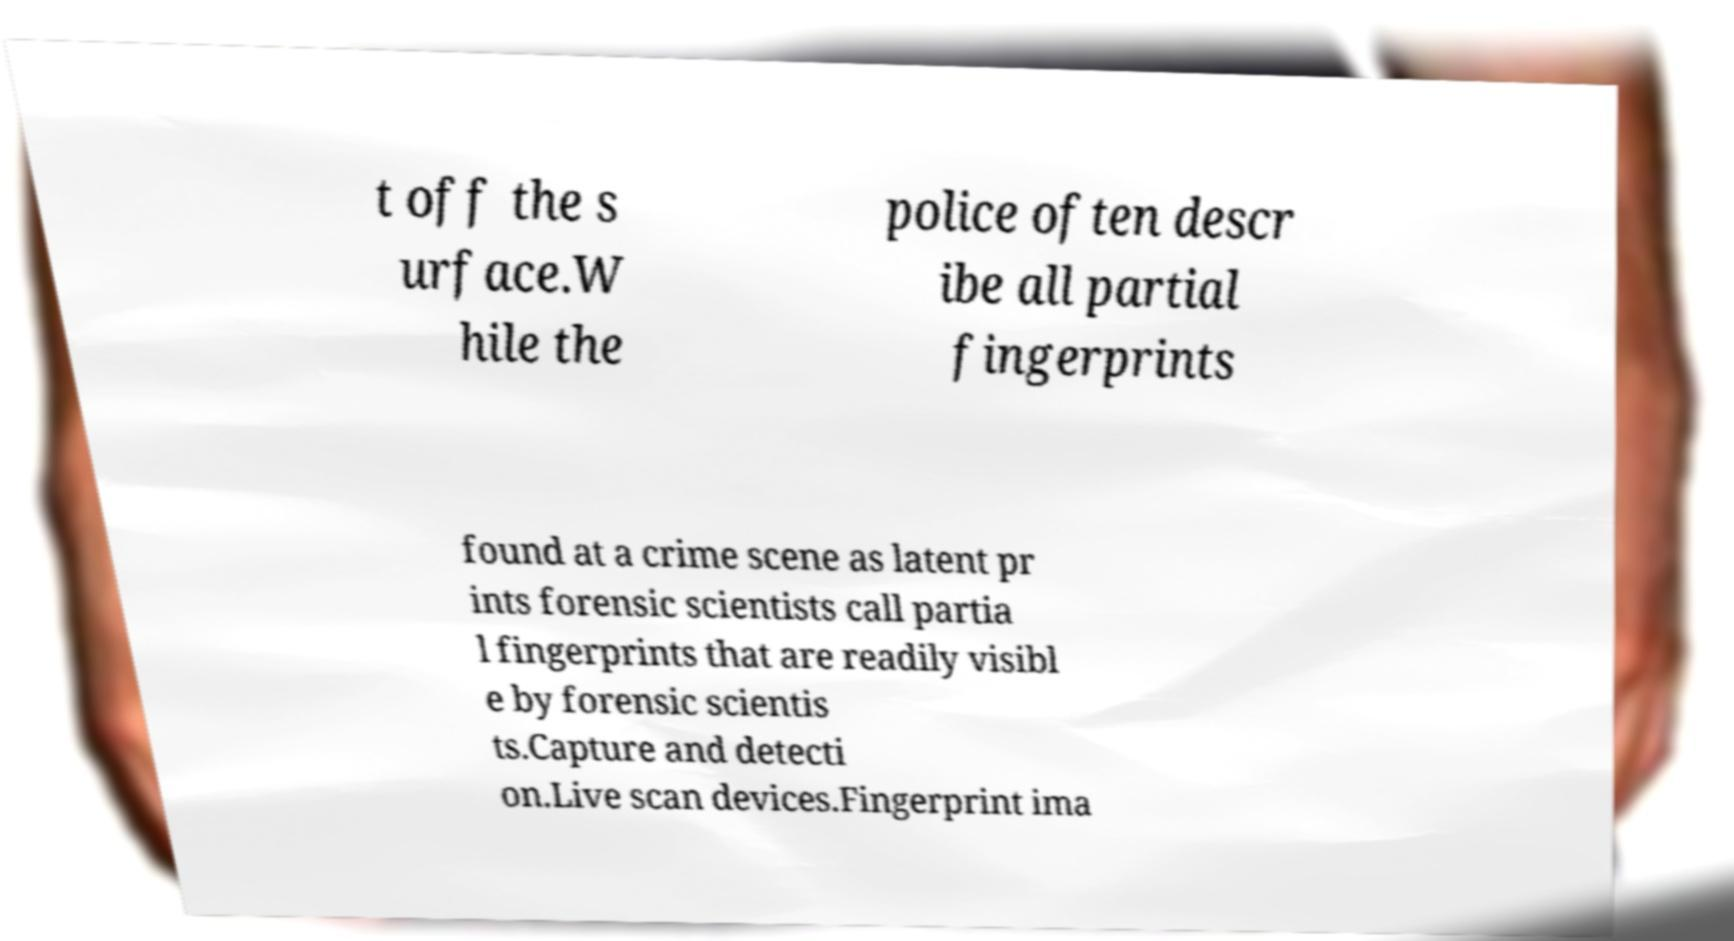What messages or text are displayed in this image? I need them in a readable, typed format. t off the s urface.W hile the police often descr ibe all partial fingerprints found at a crime scene as latent pr ints forensic scientists call partia l fingerprints that are readily visibl e by forensic scientis ts.Capture and detecti on.Live scan devices.Fingerprint ima 